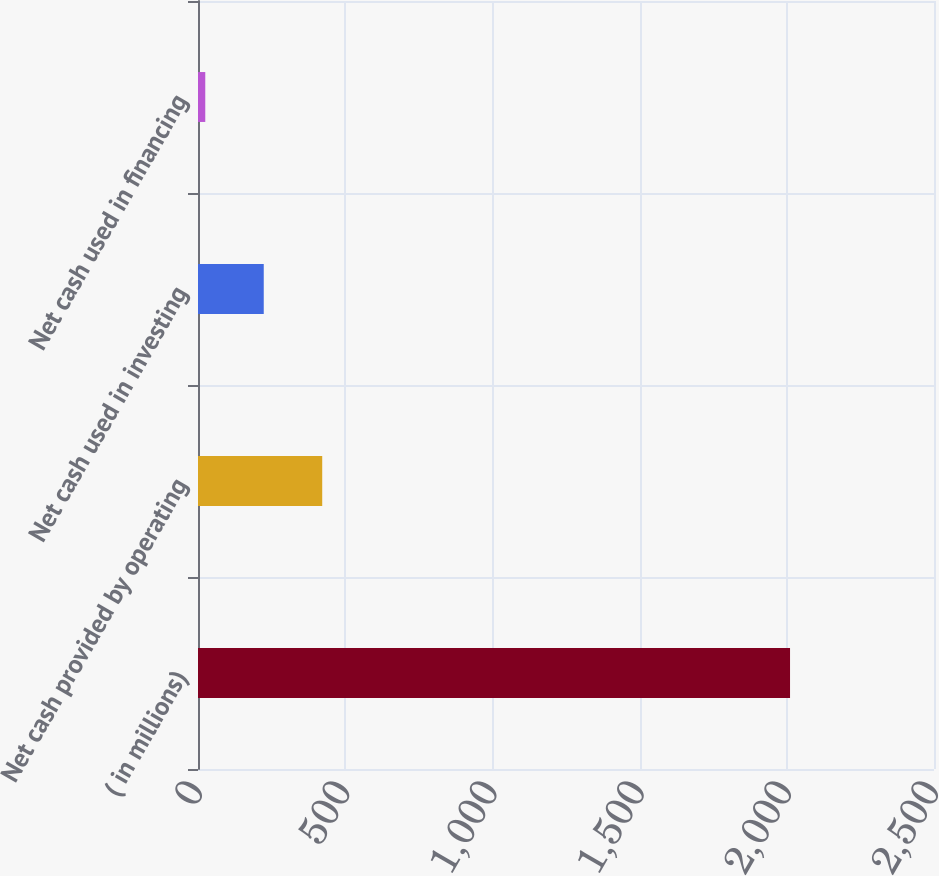<chart> <loc_0><loc_0><loc_500><loc_500><bar_chart><fcel>( in millions)<fcel>Net cash provided by operating<fcel>Net cash used in investing<fcel>Net cash used in financing<nl><fcel>2011<fcel>421.96<fcel>223.33<fcel>24.7<nl></chart> 